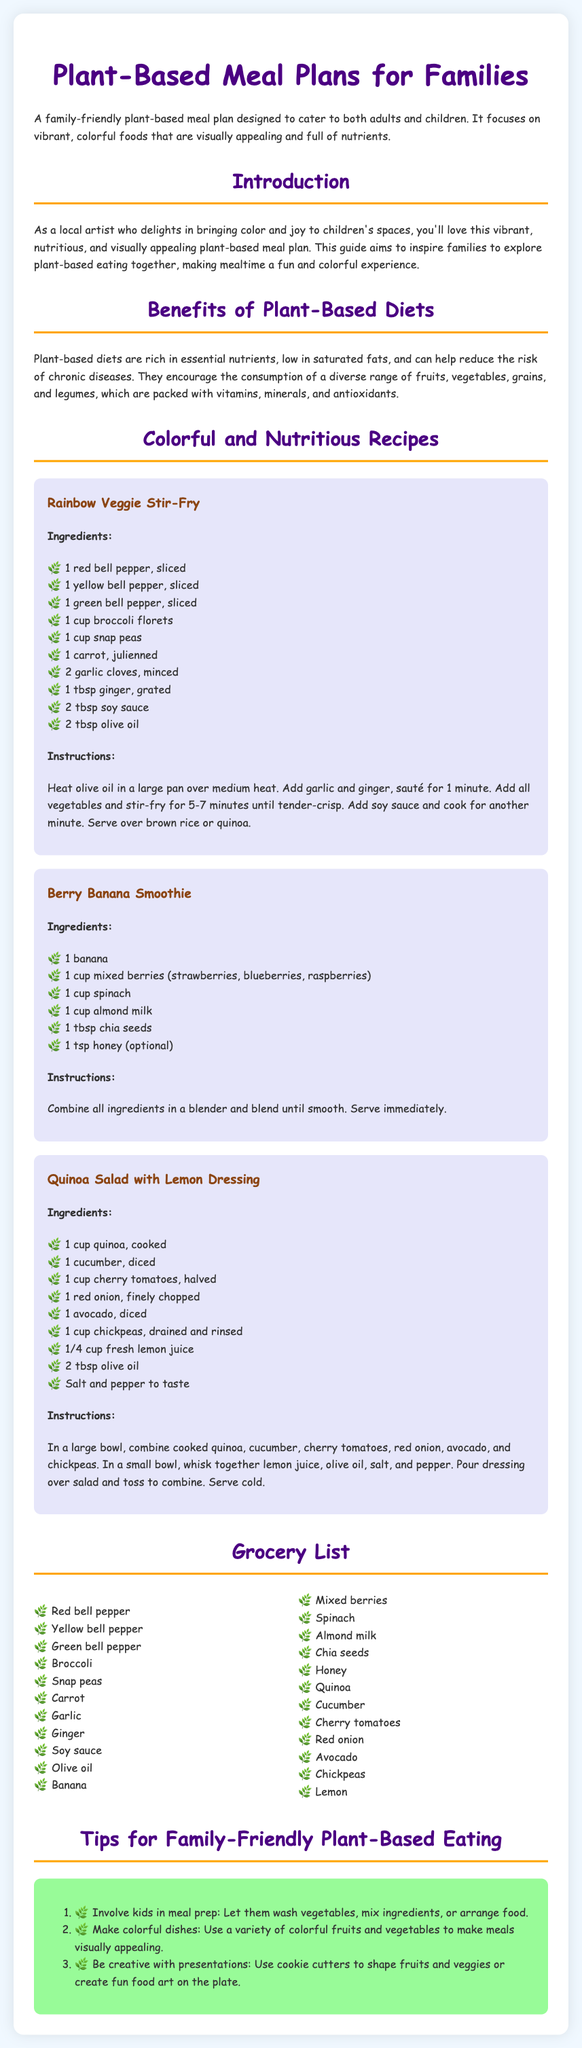what is the title of the meal plan? The main title is present at the top of the document and encapsulates the focus of the content.
Answer: Plant-Based Meal Plans for Families what are the ingredients for the Rainbow Veggie Stir-Fry? The ingredients are listed under the recipe section for Rainbow Veggie Stir-Fry.
Answer: Red bell pepper, yellow bell pepper, green bell pepper, broccoli, snap peas, carrot, garlic, ginger, soy sauce, olive oil how many recipes are included in the document? The number of recipes is found in the "Colorful and Nutritious Recipes" section.
Answer: Three what is one benefit of plant-based diets? The benefits are discussed in a dedicated section which highlights various advantages.
Answer: Reduces risk of chronic diseases name one tip for family-friendly plant-based eating. The tips are enumerated under a specific section meant to guide families in preparing meals.
Answer: Involve kids in meal prep how many columns are in the grocery list? The grocery list format is described in terms of its layout in the document.
Answer: Two what is the optional ingredient in the Berry Banana Smoothie? The optional ingredient is specified during the listing of ingredients for the smoothie recipe.
Answer: Honey which meal can be served over brown rice or quinoa? The instructions for a recipe mention what it should be served over, indicating meals that can be paired with these bases.
Answer: Rainbow Veggie Stir-Fry 